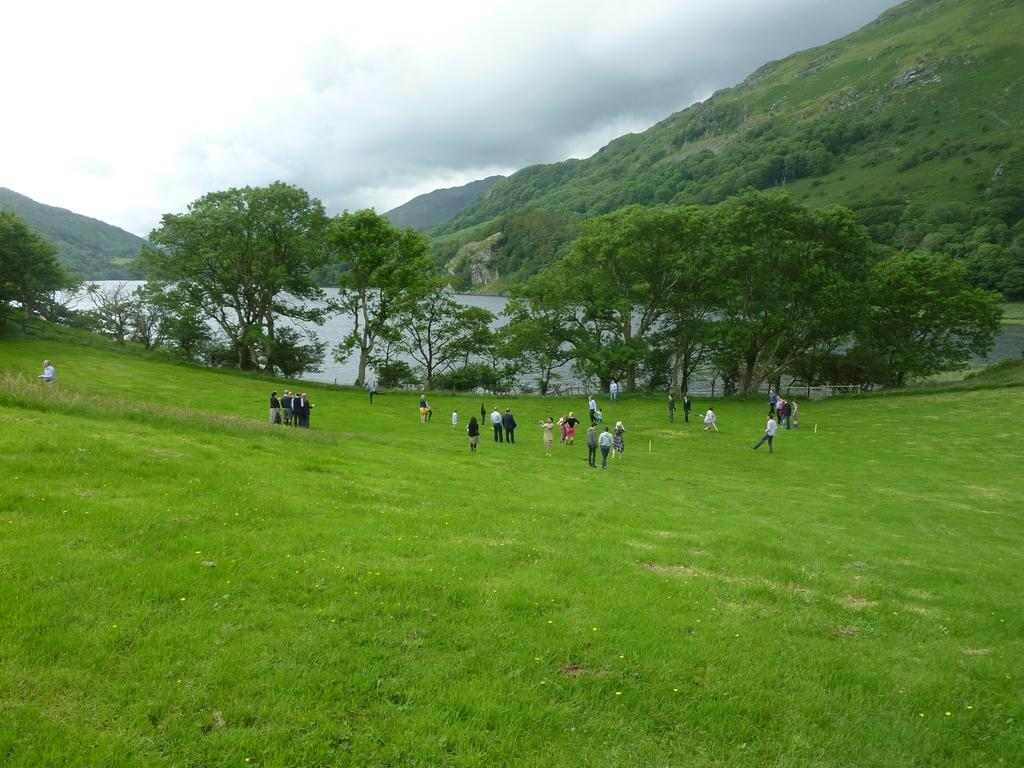What is the main activity of the people in the image? The people in the image are standing on the grass. What can be seen in the center of the image? There is water in the center of the image. What type of natural features are visible in the background of the image? There are trees and mountains in the background of the image. What part of the sky is visible in the image? The sky is visible in the background of the image. What type of popcorn is being served to the people in the image? There is no popcorn present in the image; the people are standing on the grass and there is water, trees, mountains, and sky visible in the background. Is there a bottle of water being passed around by a servant in the image? There is no servant or bottle of water present in the image. 